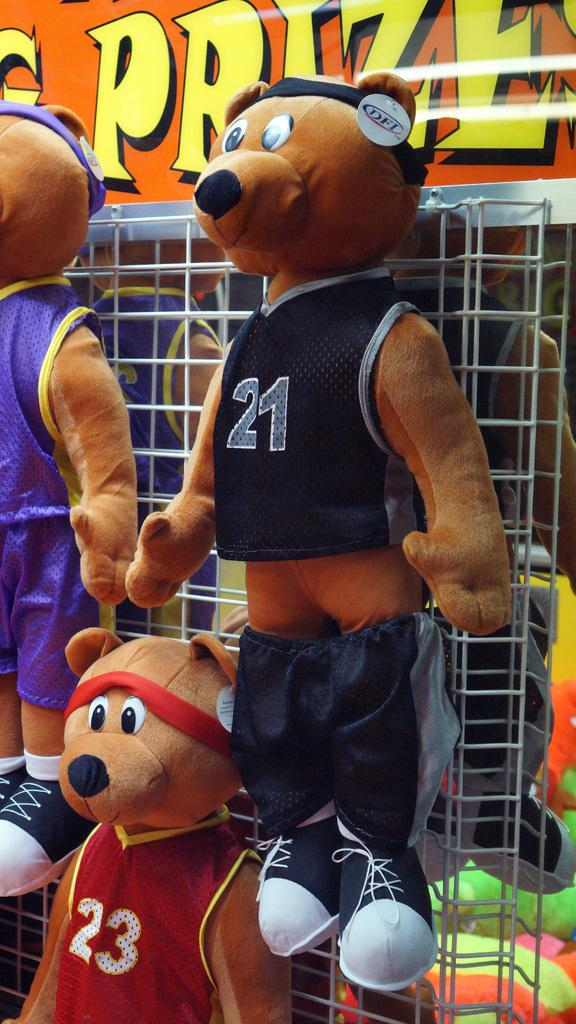<image>
Present a compact description of the photo's key features. A stuffed bear wears a red jersey with number 23. 